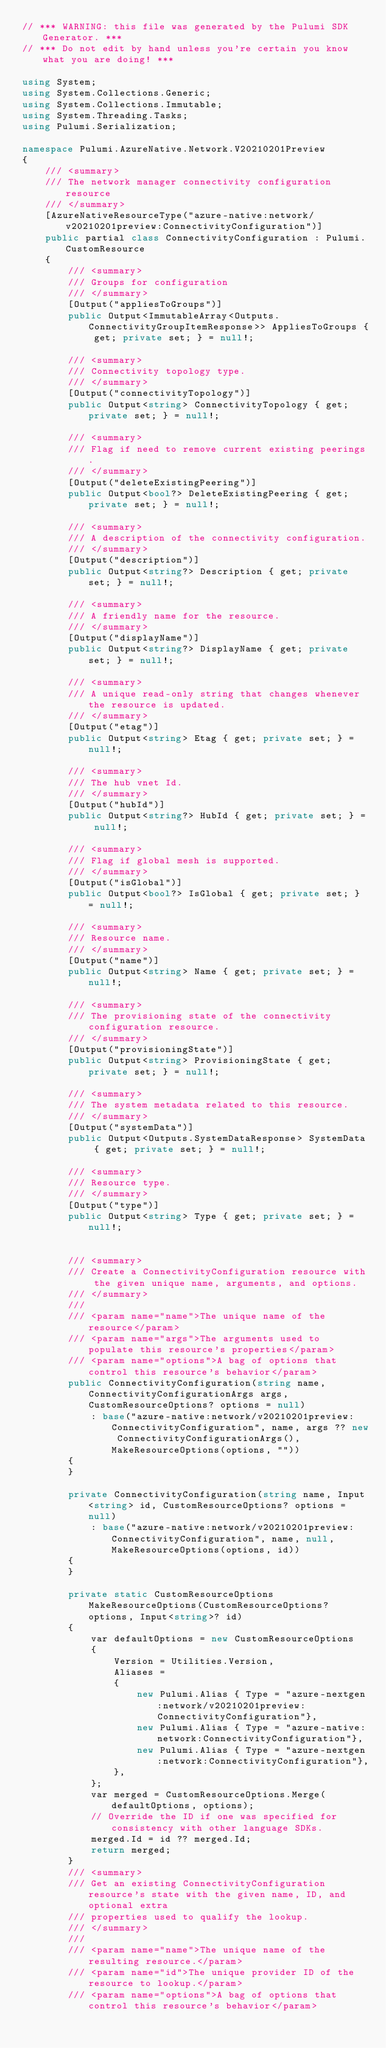<code> <loc_0><loc_0><loc_500><loc_500><_C#_>// *** WARNING: this file was generated by the Pulumi SDK Generator. ***
// *** Do not edit by hand unless you're certain you know what you are doing! ***

using System;
using System.Collections.Generic;
using System.Collections.Immutable;
using System.Threading.Tasks;
using Pulumi.Serialization;

namespace Pulumi.AzureNative.Network.V20210201Preview
{
    /// <summary>
    /// The network manager connectivity configuration resource
    /// </summary>
    [AzureNativeResourceType("azure-native:network/v20210201preview:ConnectivityConfiguration")]
    public partial class ConnectivityConfiguration : Pulumi.CustomResource
    {
        /// <summary>
        /// Groups for configuration
        /// </summary>
        [Output("appliesToGroups")]
        public Output<ImmutableArray<Outputs.ConnectivityGroupItemResponse>> AppliesToGroups { get; private set; } = null!;

        /// <summary>
        /// Connectivity topology type.
        /// </summary>
        [Output("connectivityTopology")]
        public Output<string> ConnectivityTopology { get; private set; } = null!;

        /// <summary>
        /// Flag if need to remove current existing peerings.
        /// </summary>
        [Output("deleteExistingPeering")]
        public Output<bool?> DeleteExistingPeering { get; private set; } = null!;

        /// <summary>
        /// A description of the connectivity configuration.
        /// </summary>
        [Output("description")]
        public Output<string?> Description { get; private set; } = null!;

        /// <summary>
        /// A friendly name for the resource.
        /// </summary>
        [Output("displayName")]
        public Output<string?> DisplayName { get; private set; } = null!;

        /// <summary>
        /// A unique read-only string that changes whenever the resource is updated.
        /// </summary>
        [Output("etag")]
        public Output<string> Etag { get; private set; } = null!;

        /// <summary>
        /// The hub vnet Id.
        /// </summary>
        [Output("hubId")]
        public Output<string?> HubId { get; private set; } = null!;

        /// <summary>
        /// Flag if global mesh is supported.
        /// </summary>
        [Output("isGlobal")]
        public Output<bool?> IsGlobal { get; private set; } = null!;

        /// <summary>
        /// Resource name.
        /// </summary>
        [Output("name")]
        public Output<string> Name { get; private set; } = null!;

        /// <summary>
        /// The provisioning state of the connectivity configuration resource.
        /// </summary>
        [Output("provisioningState")]
        public Output<string> ProvisioningState { get; private set; } = null!;

        /// <summary>
        /// The system metadata related to this resource.
        /// </summary>
        [Output("systemData")]
        public Output<Outputs.SystemDataResponse> SystemData { get; private set; } = null!;

        /// <summary>
        /// Resource type.
        /// </summary>
        [Output("type")]
        public Output<string> Type { get; private set; } = null!;


        /// <summary>
        /// Create a ConnectivityConfiguration resource with the given unique name, arguments, and options.
        /// </summary>
        ///
        /// <param name="name">The unique name of the resource</param>
        /// <param name="args">The arguments used to populate this resource's properties</param>
        /// <param name="options">A bag of options that control this resource's behavior</param>
        public ConnectivityConfiguration(string name, ConnectivityConfigurationArgs args, CustomResourceOptions? options = null)
            : base("azure-native:network/v20210201preview:ConnectivityConfiguration", name, args ?? new ConnectivityConfigurationArgs(), MakeResourceOptions(options, ""))
        {
        }

        private ConnectivityConfiguration(string name, Input<string> id, CustomResourceOptions? options = null)
            : base("azure-native:network/v20210201preview:ConnectivityConfiguration", name, null, MakeResourceOptions(options, id))
        {
        }

        private static CustomResourceOptions MakeResourceOptions(CustomResourceOptions? options, Input<string>? id)
        {
            var defaultOptions = new CustomResourceOptions
            {
                Version = Utilities.Version,
                Aliases =
                {
                    new Pulumi.Alias { Type = "azure-nextgen:network/v20210201preview:ConnectivityConfiguration"},
                    new Pulumi.Alias { Type = "azure-native:network:ConnectivityConfiguration"},
                    new Pulumi.Alias { Type = "azure-nextgen:network:ConnectivityConfiguration"},
                },
            };
            var merged = CustomResourceOptions.Merge(defaultOptions, options);
            // Override the ID if one was specified for consistency with other language SDKs.
            merged.Id = id ?? merged.Id;
            return merged;
        }
        /// <summary>
        /// Get an existing ConnectivityConfiguration resource's state with the given name, ID, and optional extra
        /// properties used to qualify the lookup.
        /// </summary>
        ///
        /// <param name="name">The unique name of the resulting resource.</param>
        /// <param name="id">The unique provider ID of the resource to lookup.</param>
        /// <param name="options">A bag of options that control this resource's behavior</param></code> 